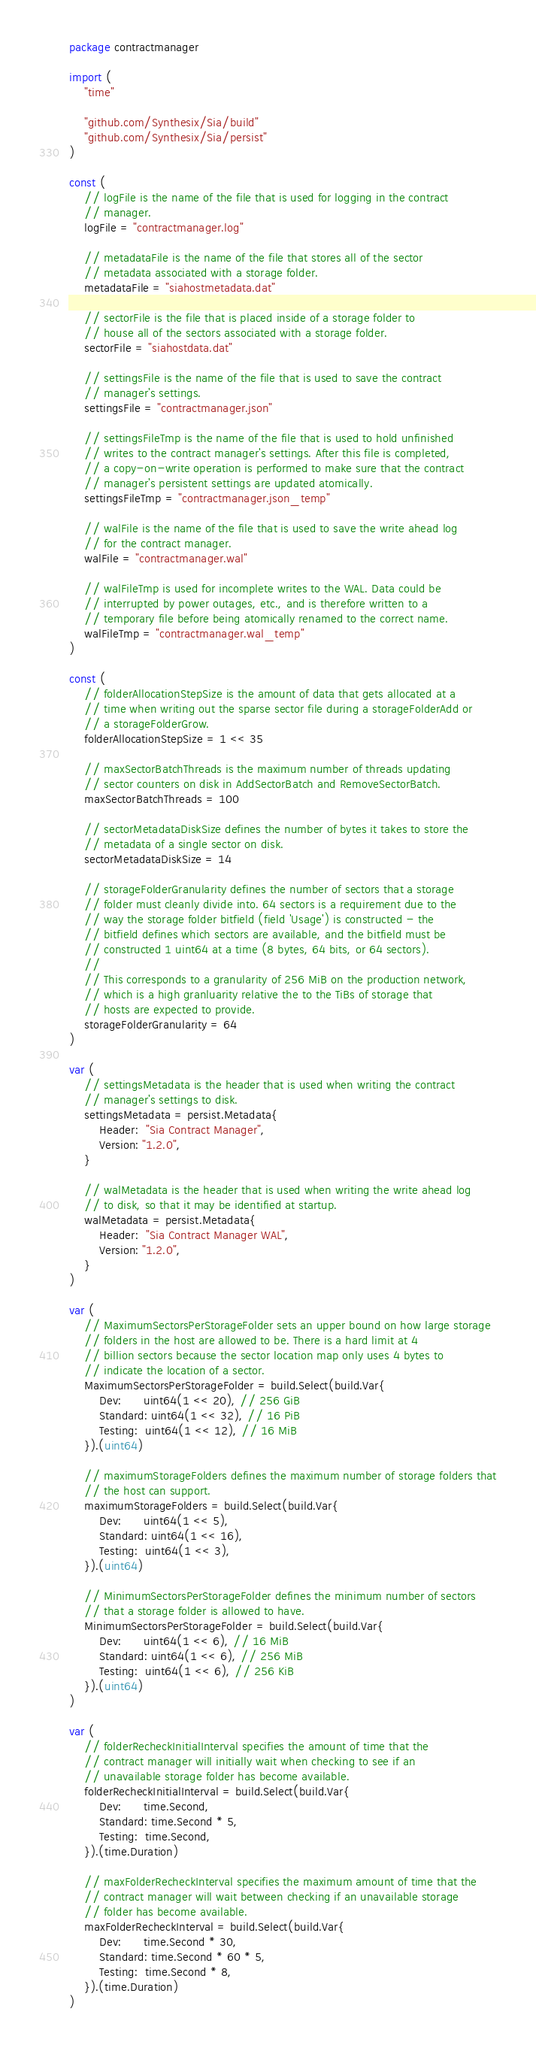Convert code to text. <code><loc_0><loc_0><loc_500><loc_500><_Go_>package contractmanager

import (
	"time"

	"github.com/Synthesix/Sia/build"
	"github.com/Synthesix/Sia/persist"
)

const (
	// logFile is the name of the file that is used for logging in the contract
	// manager.
	logFile = "contractmanager.log"

	// metadataFile is the name of the file that stores all of the sector
	// metadata associated with a storage folder.
	metadataFile = "siahostmetadata.dat"

	// sectorFile is the file that is placed inside of a storage folder to
	// house all of the sectors associated with a storage folder.
	sectorFile = "siahostdata.dat"

	// settingsFile is the name of the file that is used to save the contract
	// manager's settings.
	settingsFile = "contractmanager.json"

	// settingsFileTmp is the name of the file that is used to hold unfinished
	// writes to the contract manager's settings. After this file is completed,
	// a copy-on-write operation is performed to make sure that the contract
	// manager's persistent settings are updated atomically.
	settingsFileTmp = "contractmanager.json_temp"

	// walFile is the name of the file that is used to save the write ahead log
	// for the contract manager.
	walFile = "contractmanager.wal"

	// walFileTmp is used for incomplete writes to the WAL. Data could be
	// interrupted by power outages, etc., and is therefore written to a
	// temporary file before being atomically renamed to the correct name.
	walFileTmp = "contractmanager.wal_temp"
)

const (
	// folderAllocationStepSize is the amount of data that gets allocated at a
	// time when writing out the sparse sector file during a storageFolderAdd or
	// a storageFolderGrow.
	folderAllocationStepSize = 1 << 35

	// maxSectorBatchThreads is the maximum number of threads updating
	// sector counters on disk in AddSectorBatch and RemoveSectorBatch.
	maxSectorBatchThreads = 100

	// sectorMetadataDiskSize defines the number of bytes it takes to store the
	// metadata of a single sector on disk.
	sectorMetadataDiskSize = 14

	// storageFolderGranularity defines the number of sectors that a storage
	// folder must cleanly divide into. 64 sectors is a requirement due to the
	// way the storage folder bitfield (field 'Usage') is constructed - the
	// bitfield defines which sectors are available, and the bitfield must be
	// constructed 1 uint64 at a time (8 bytes, 64 bits, or 64 sectors).
	//
	// This corresponds to a granularity of 256 MiB on the production network,
	// which is a high granluarity relative the to the TiBs of storage that
	// hosts are expected to provide.
	storageFolderGranularity = 64
)

var (
	// settingsMetadata is the header that is used when writing the contract
	// manager's settings to disk.
	settingsMetadata = persist.Metadata{
		Header:  "Sia Contract Manager",
		Version: "1.2.0",
	}

	// walMetadata is the header that is used when writing the write ahead log
	// to disk, so that it may be identified at startup.
	walMetadata = persist.Metadata{
		Header:  "Sia Contract Manager WAL",
		Version: "1.2.0",
	}
)

var (
	// MaximumSectorsPerStorageFolder sets an upper bound on how large storage
	// folders in the host are allowed to be. There is a hard limit at 4
	// billion sectors because the sector location map only uses 4 bytes to
	// indicate the location of a sector.
	MaximumSectorsPerStorageFolder = build.Select(build.Var{
		Dev:      uint64(1 << 20), // 256 GiB
		Standard: uint64(1 << 32), // 16 PiB
		Testing:  uint64(1 << 12), // 16 MiB
	}).(uint64)

	// maximumStorageFolders defines the maximum number of storage folders that
	// the host can support.
	maximumStorageFolders = build.Select(build.Var{
		Dev:      uint64(1 << 5),
		Standard: uint64(1 << 16),
		Testing:  uint64(1 << 3),
	}).(uint64)

	// MinimumSectorsPerStorageFolder defines the minimum number of sectors
	// that a storage folder is allowed to have.
	MinimumSectorsPerStorageFolder = build.Select(build.Var{
		Dev:      uint64(1 << 6), // 16 MiB
		Standard: uint64(1 << 6), // 256 MiB
		Testing:  uint64(1 << 6), // 256 KiB
	}).(uint64)
)

var (
	// folderRecheckInitialInterval specifies the amount of time that the
	// contract manager will initially wait when checking to see if an
	// unavailable storage folder has become available.
	folderRecheckInitialInterval = build.Select(build.Var{
		Dev:      time.Second,
		Standard: time.Second * 5,
		Testing:  time.Second,
	}).(time.Duration)

	// maxFolderRecheckInterval specifies the maximum amount of time that the
	// contract manager will wait between checking if an unavailable storage
	// folder has become available.
	maxFolderRecheckInterval = build.Select(build.Var{
		Dev:      time.Second * 30,
		Standard: time.Second * 60 * 5,
		Testing:  time.Second * 8,
	}).(time.Duration)
)
</code> 